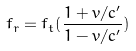Convert formula to latex. <formula><loc_0><loc_0><loc_500><loc_500>f _ { r } = f _ { t } ( \frac { 1 + v / c ^ { \prime } } { 1 - v / c ^ { \prime } } )</formula> 